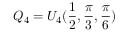Convert formula to latex. <formula><loc_0><loc_0><loc_500><loc_500>Q _ { 4 } = U _ { 4 } ( \frac { 1 } { 2 } , \frac { \pi } { 3 } , \frac { \pi } { 6 } )</formula> 